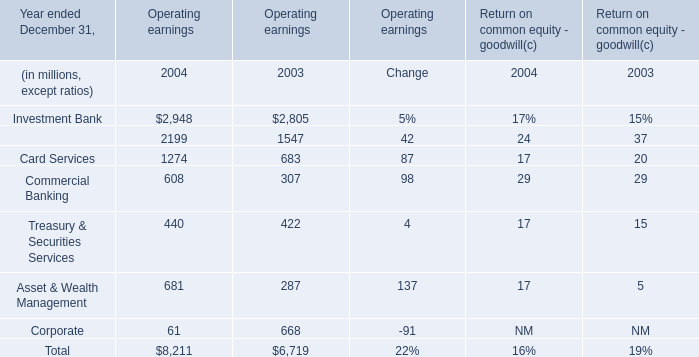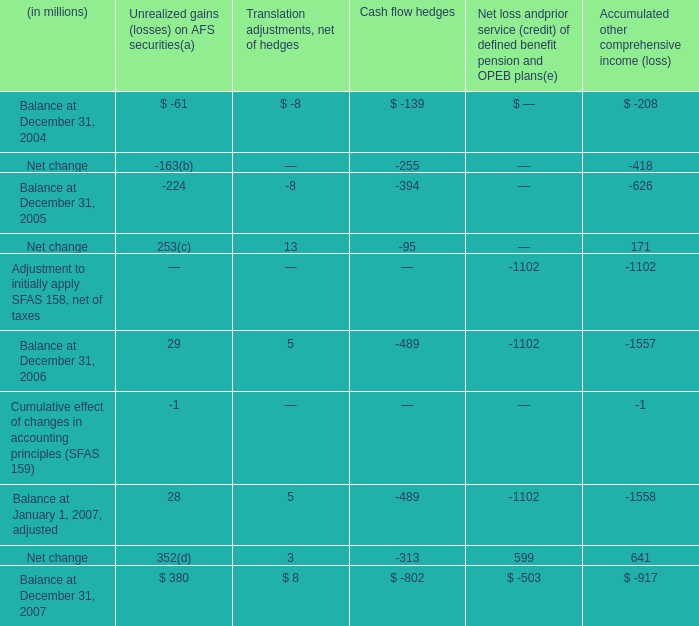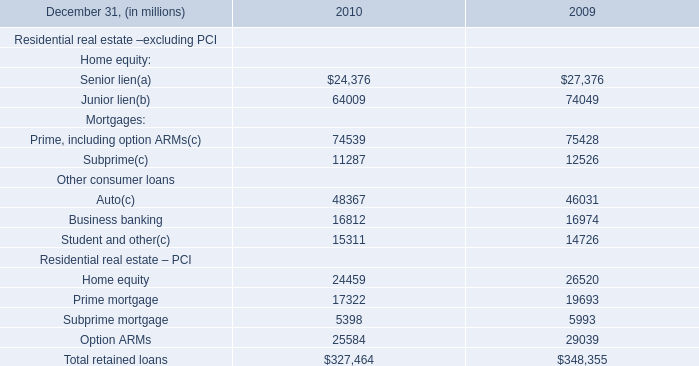What's the average of Retail Financial Services of Operating earnings 2003, and Home equity Residential real estate – PCI of 2010 ? 
Computations: ((1547.0 + 24459.0) / 2)
Answer: 13003.0. 